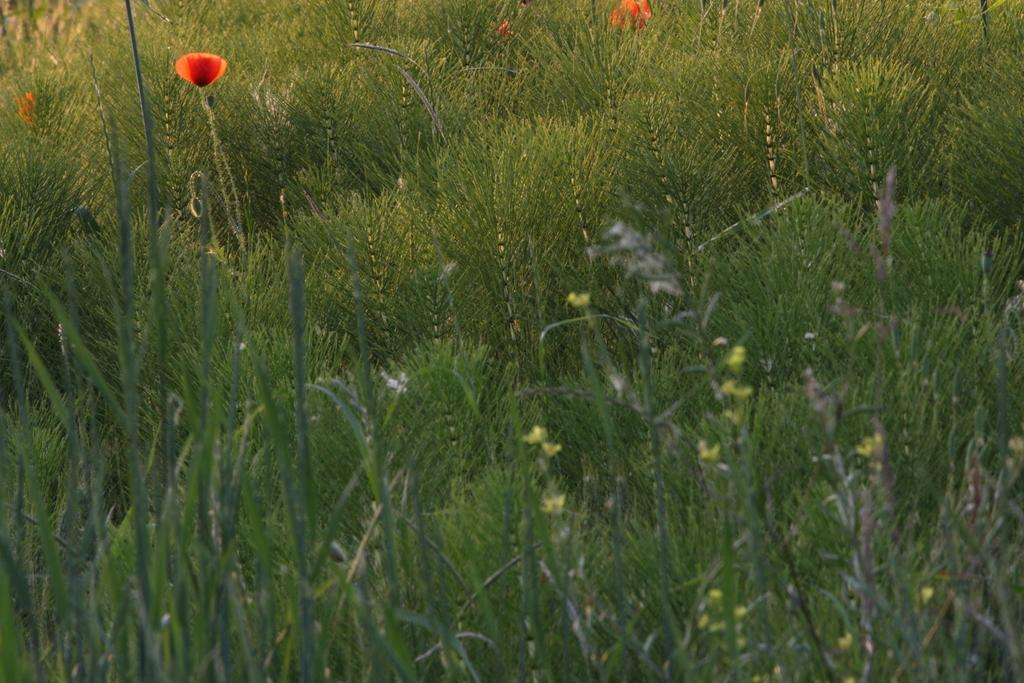What colors are the flowers in the image? The flowers in the image are orange and yellow in color. What color are the plants in the image? The plants in the image are green in color. How much mass do the flowers have in the image? The mass of the flowers cannot be determined from the image alone, as it does not provide information about the size or weight of the flowers. What type of wealth is depicted in the image? There is no depiction of wealth in the image; it features flowers and plants. 